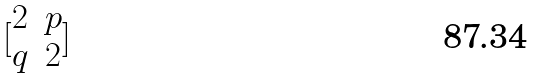<formula> <loc_0><loc_0><loc_500><loc_500>[ \begin{matrix} 2 & p \\ q & 2 \end{matrix} ]</formula> 